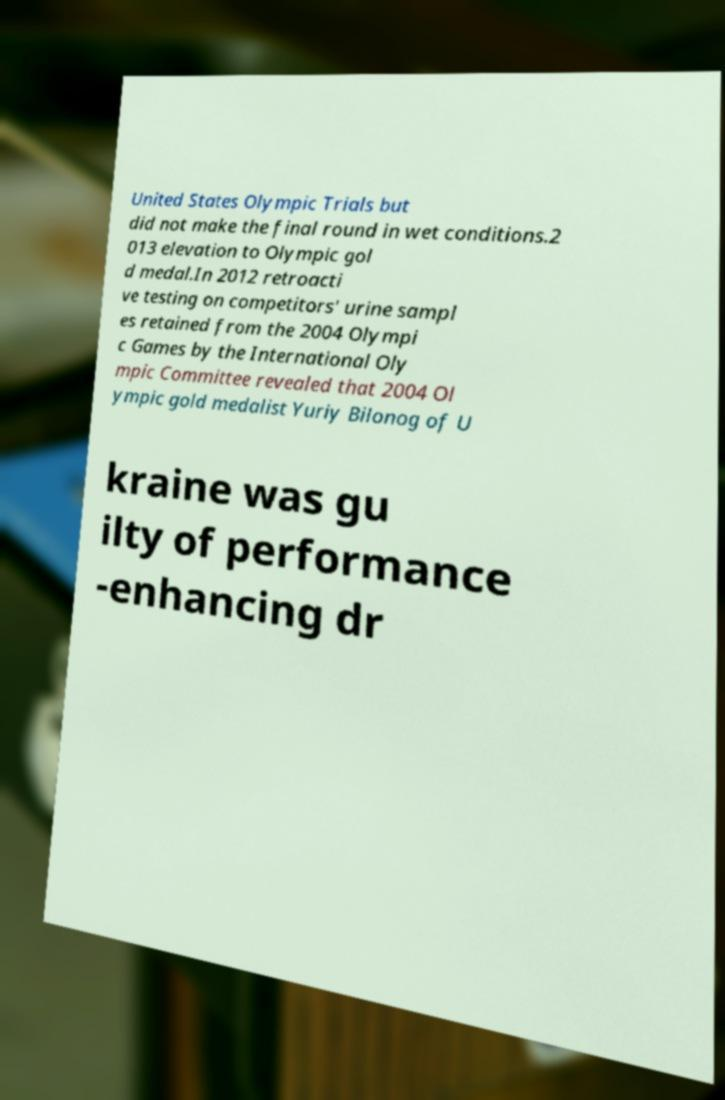Could you assist in decoding the text presented in this image and type it out clearly? United States Olympic Trials but did not make the final round in wet conditions.2 013 elevation to Olympic gol d medal.In 2012 retroacti ve testing on competitors' urine sampl es retained from the 2004 Olympi c Games by the International Oly mpic Committee revealed that 2004 Ol ympic gold medalist Yuriy Bilonog of U kraine was gu ilty of performance -enhancing dr 